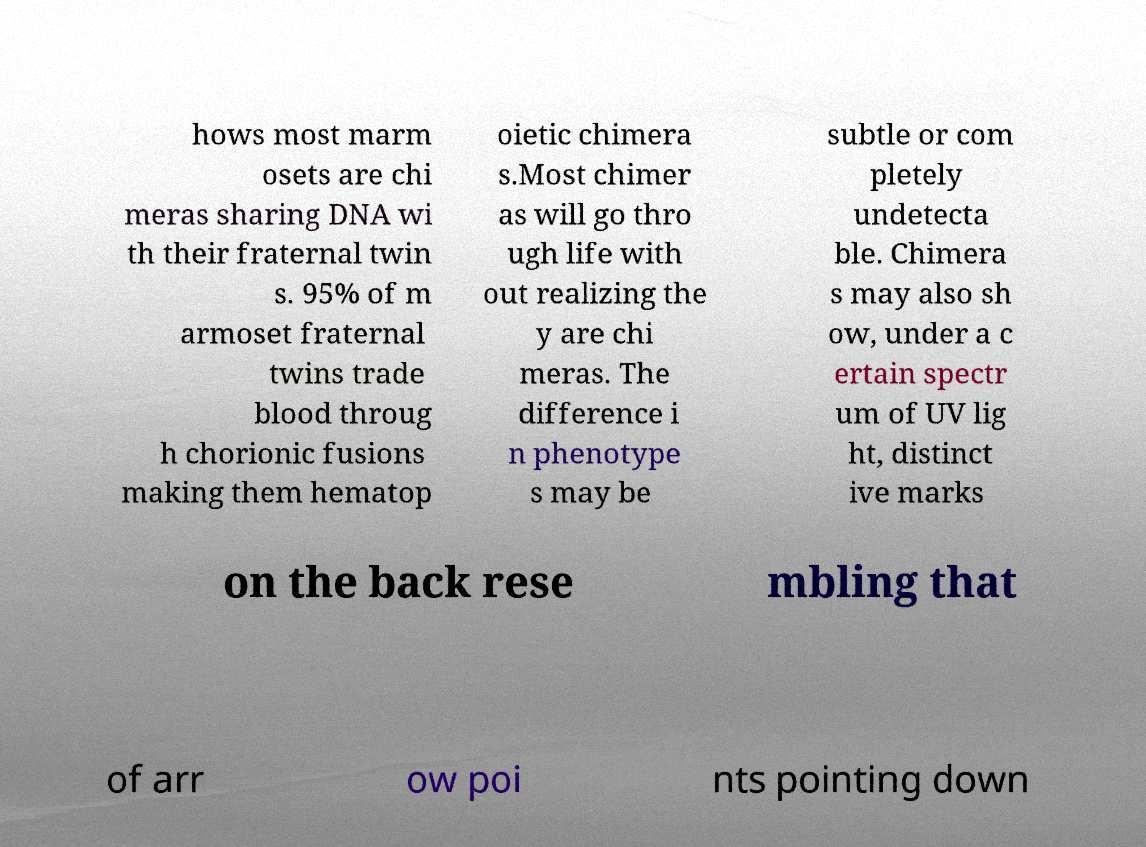Please read and relay the text visible in this image. What does it say? hows most marm osets are chi meras sharing DNA wi th their fraternal twin s. 95% of m armoset fraternal twins trade blood throug h chorionic fusions making them hematop oietic chimera s.Most chimer as will go thro ugh life with out realizing the y are chi meras. The difference i n phenotype s may be subtle or com pletely undetecta ble. Chimera s may also sh ow, under a c ertain spectr um of UV lig ht, distinct ive marks on the back rese mbling that of arr ow poi nts pointing down 